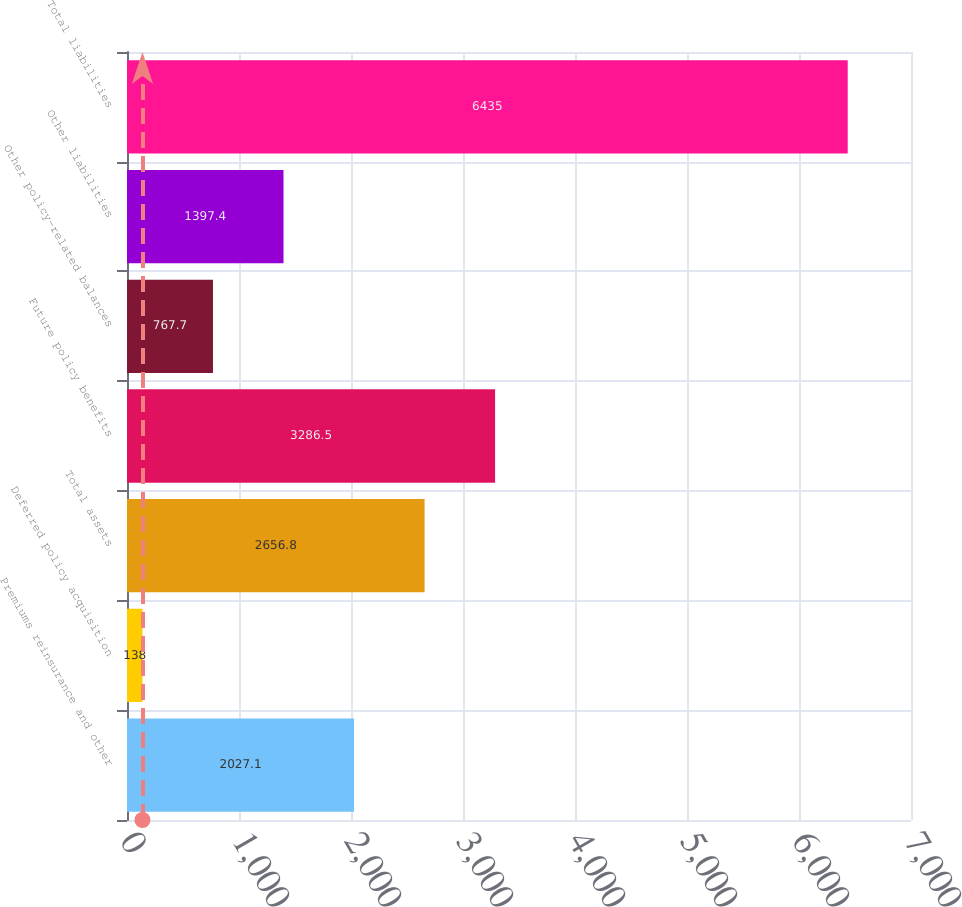<chart> <loc_0><loc_0><loc_500><loc_500><bar_chart><fcel>Premiums reinsurance and other<fcel>Deferred policy acquisition<fcel>Total assets<fcel>Future policy benefits<fcel>Other policy-related balances<fcel>Other liabilities<fcel>Total liabilities<nl><fcel>2027.1<fcel>138<fcel>2656.8<fcel>3286.5<fcel>767.7<fcel>1397.4<fcel>6435<nl></chart> 